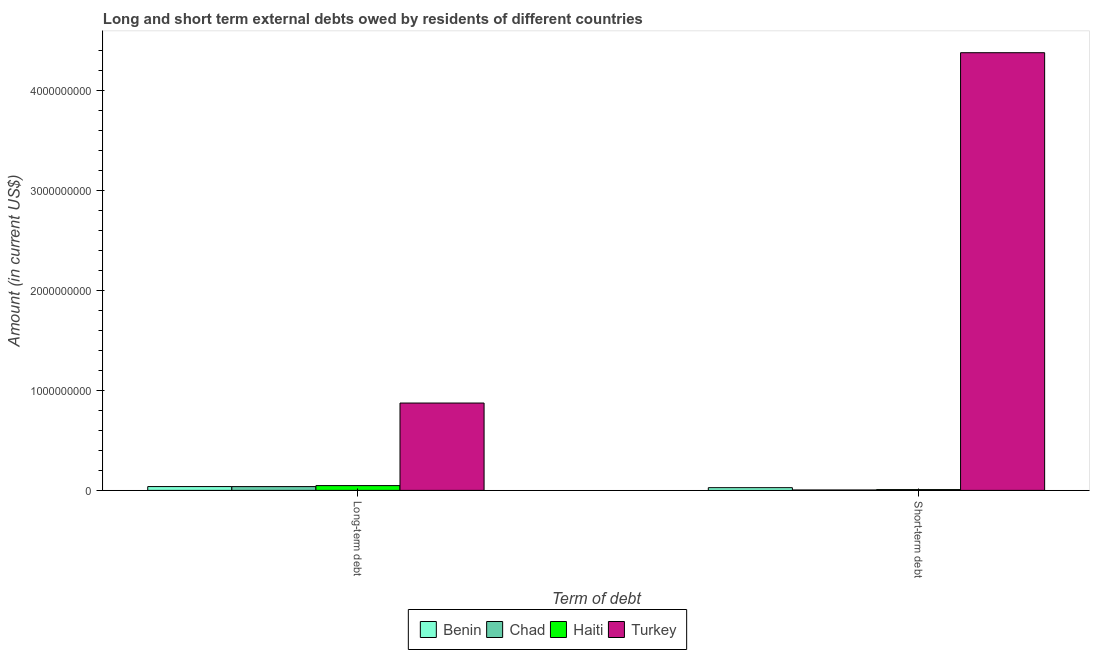How many groups of bars are there?
Your answer should be very brief. 2. Are the number of bars per tick equal to the number of legend labels?
Your answer should be compact. Yes. Are the number of bars on each tick of the X-axis equal?
Your response must be concise. Yes. How many bars are there on the 2nd tick from the left?
Offer a terse response. 4. How many bars are there on the 2nd tick from the right?
Make the answer very short. 4. What is the label of the 1st group of bars from the left?
Keep it short and to the point. Long-term debt. What is the short-term debts owed by residents in Chad?
Keep it short and to the point. 4.00e+06. Across all countries, what is the maximum long-term debts owed by residents?
Keep it short and to the point. 8.74e+08. Across all countries, what is the minimum short-term debts owed by residents?
Ensure brevity in your answer.  4.00e+06. In which country was the short-term debts owed by residents minimum?
Provide a succinct answer. Chad. What is the total short-term debts owed by residents in the graph?
Make the answer very short. 4.42e+09. What is the difference between the long-term debts owed by residents in Benin and that in Haiti?
Your answer should be compact. -9.67e+06. What is the difference between the long-term debts owed by residents in Benin and the short-term debts owed by residents in Turkey?
Provide a short and direct response. -4.34e+09. What is the average short-term debts owed by residents per country?
Your answer should be very brief. 1.10e+09. What is the difference between the short-term debts owed by residents and long-term debts owed by residents in Turkey?
Offer a very short reply. 3.51e+09. In how many countries, is the short-term debts owed by residents greater than 2800000000 US$?
Your answer should be very brief. 1. What is the ratio of the long-term debts owed by residents in Turkey to that in Chad?
Provide a succinct answer. 23.07. What does the 1st bar from the left in Long-term debt represents?
Keep it short and to the point. Benin. What does the 1st bar from the right in Long-term debt represents?
Keep it short and to the point. Turkey. How many countries are there in the graph?
Make the answer very short. 4. What is the difference between two consecutive major ticks on the Y-axis?
Keep it short and to the point. 1.00e+09. How many legend labels are there?
Your answer should be compact. 4. What is the title of the graph?
Ensure brevity in your answer.  Long and short term external debts owed by residents of different countries. What is the label or title of the X-axis?
Provide a succinct answer. Term of debt. What is the label or title of the Y-axis?
Provide a succinct answer. Amount (in current US$). What is the Amount (in current US$) in Benin in Long-term debt?
Make the answer very short. 3.82e+07. What is the Amount (in current US$) in Chad in Long-term debt?
Keep it short and to the point. 3.79e+07. What is the Amount (in current US$) of Haiti in Long-term debt?
Make the answer very short. 4.78e+07. What is the Amount (in current US$) of Turkey in Long-term debt?
Your response must be concise. 8.74e+08. What is the Amount (in current US$) in Benin in Short-term debt?
Your answer should be compact. 2.70e+07. What is the Amount (in current US$) of Chad in Short-term debt?
Provide a succinct answer. 4.00e+06. What is the Amount (in current US$) in Turkey in Short-term debt?
Your response must be concise. 4.38e+09. Across all Term of debt, what is the maximum Amount (in current US$) in Benin?
Offer a terse response. 3.82e+07. Across all Term of debt, what is the maximum Amount (in current US$) in Chad?
Your response must be concise. 3.79e+07. Across all Term of debt, what is the maximum Amount (in current US$) of Haiti?
Your answer should be very brief. 4.78e+07. Across all Term of debt, what is the maximum Amount (in current US$) of Turkey?
Ensure brevity in your answer.  4.38e+09. Across all Term of debt, what is the minimum Amount (in current US$) in Benin?
Ensure brevity in your answer.  2.70e+07. Across all Term of debt, what is the minimum Amount (in current US$) of Chad?
Provide a short and direct response. 4.00e+06. Across all Term of debt, what is the minimum Amount (in current US$) of Haiti?
Offer a very short reply. 8.00e+06. Across all Term of debt, what is the minimum Amount (in current US$) in Turkey?
Offer a terse response. 8.74e+08. What is the total Amount (in current US$) of Benin in the graph?
Keep it short and to the point. 6.52e+07. What is the total Amount (in current US$) in Chad in the graph?
Give a very brief answer. 4.19e+07. What is the total Amount (in current US$) of Haiti in the graph?
Your answer should be very brief. 5.58e+07. What is the total Amount (in current US$) of Turkey in the graph?
Your response must be concise. 5.25e+09. What is the difference between the Amount (in current US$) in Benin in Long-term debt and that in Short-term debt?
Offer a very short reply. 1.12e+07. What is the difference between the Amount (in current US$) in Chad in Long-term debt and that in Short-term debt?
Offer a terse response. 3.39e+07. What is the difference between the Amount (in current US$) of Haiti in Long-term debt and that in Short-term debt?
Ensure brevity in your answer.  3.98e+07. What is the difference between the Amount (in current US$) of Turkey in Long-term debt and that in Short-term debt?
Ensure brevity in your answer.  -3.51e+09. What is the difference between the Amount (in current US$) in Benin in Long-term debt and the Amount (in current US$) in Chad in Short-term debt?
Provide a succinct answer. 3.42e+07. What is the difference between the Amount (in current US$) in Benin in Long-term debt and the Amount (in current US$) in Haiti in Short-term debt?
Your response must be concise. 3.02e+07. What is the difference between the Amount (in current US$) in Benin in Long-term debt and the Amount (in current US$) in Turkey in Short-term debt?
Ensure brevity in your answer.  -4.34e+09. What is the difference between the Amount (in current US$) of Chad in Long-term debt and the Amount (in current US$) of Haiti in Short-term debt?
Keep it short and to the point. 2.99e+07. What is the difference between the Amount (in current US$) of Chad in Long-term debt and the Amount (in current US$) of Turkey in Short-term debt?
Your answer should be very brief. -4.34e+09. What is the difference between the Amount (in current US$) in Haiti in Long-term debt and the Amount (in current US$) in Turkey in Short-term debt?
Your answer should be very brief. -4.33e+09. What is the average Amount (in current US$) in Benin per Term of debt?
Offer a terse response. 3.26e+07. What is the average Amount (in current US$) of Chad per Term of debt?
Offer a terse response. 2.09e+07. What is the average Amount (in current US$) in Haiti per Term of debt?
Your response must be concise. 2.79e+07. What is the average Amount (in current US$) of Turkey per Term of debt?
Give a very brief answer. 2.63e+09. What is the difference between the Amount (in current US$) in Benin and Amount (in current US$) in Chad in Long-term debt?
Offer a terse response. 2.69e+05. What is the difference between the Amount (in current US$) of Benin and Amount (in current US$) of Haiti in Long-term debt?
Provide a short and direct response. -9.67e+06. What is the difference between the Amount (in current US$) in Benin and Amount (in current US$) in Turkey in Long-term debt?
Offer a terse response. -8.36e+08. What is the difference between the Amount (in current US$) of Chad and Amount (in current US$) of Haiti in Long-term debt?
Provide a succinct answer. -9.94e+06. What is the difference between the Amount (in current US$) of Chad and Amount (in current US$) of Turkey in Long-term debt?
Your answer should be compact. -8.36e+08. What is the difference between the Amount (in current US$) in Haiti and Amount (in current US$) in Turkey in Long-term debt?
Your answer should be very brief. -8.26e+08. What is the difference between the Amount (in current US$) of Benin and Amount (in current US$) of Chad in Short-term debt?
Keep it short and to the point. 2.30e+07. What is the difference between the Amount (in current US$) in Benin and Amount (in current US$) in Haiti in Short-term debt?
Your answer should be very brief. 1.90e+07. What is the difference between the Amount (in current US$) in Benin and Amount (in current US$) in Turkey in Short-term debt?
Offer a terse response. -4.35e+09. What is the difference between the Amount (in current US$) in Chad and Amount (in current US$) in Turkey in Short-term debt?
Give a very brief answer. -4.38e+09. What is the difference between the Amount (in current US$) in Haiti and Amount (in current US$) in Turkey in Short-term debt?
Your answer should be very brief. -4.37e+09. What is the ratio of the Amount (in current US$) in Benin in Long-term debt to that in Short-term debt?
Keep it short and to the point. 1.41. What is the ratio of the Amount (in current US$) in Chad in Long-term debt to that in Short-term debt?
Give a very brief answer. 9.47. What is the ratio of the Amount (in current US$) in Haiti in Long-term debt to that in Short-term debt?
Give a very brief answer. 5.98. What is the ratio of the Amount (in current US$) of Turkey in Long-term debt to that in Short-term debt?
Provide a short and direct response. 0.2. What is the difference between the highest and the second highest Amount (in current US$) in Benin?
Provide a short and direct response. 1.12e+07. What is the difference between the highest and the second highest Amount (in current US$) of Chad?
Keep it short and to the point. 3.39e+07. What is the difference between the highest and the second highest Amount (in current US$) in Haiti?
Offer a terse response. 3.98e+07. What is the difference between the highest and the second highest Amount (in current US$) in Turkey?
Make the answer very short. 3.51e+09. What is the difference between the highest and the lowest Amount (in current US$) in Benin?
Make the answer very short. 1.12e+07. What is the difference between the highest and the lowest Amount (in current US$) of Chad?
Provide a succinct answer. 3.39e+07. What is the difference between the highest and the lowest Amount (in current US$) of Haiti?
Your answer should be compact. 3.98e+07. What is the difference between the highest and the lowest Amount (in current US$) of Turkey?
Make the answer very short. 3.51e+09. 